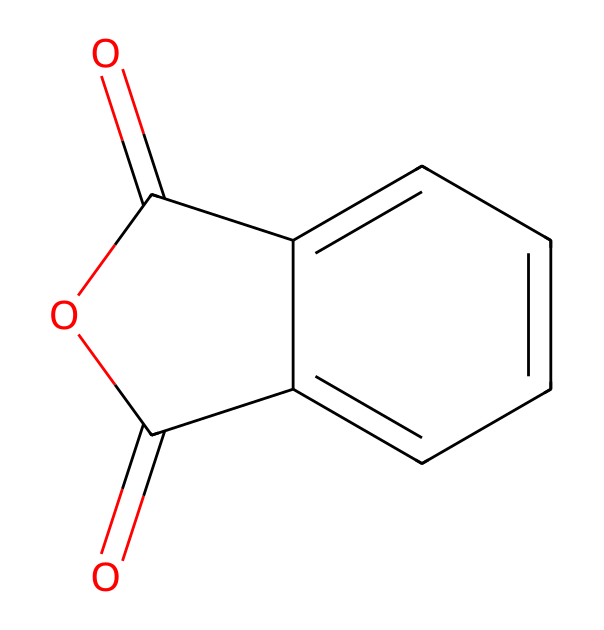What is the name of this chemical? The chemical structure given corresponds to phthalic anhydride, as indicated by the specific arrangement of carbon and oxygen atoms forming an anhydride.
Answer: phthalic anhydride How many carbon atoms are present in this compound? By analyzing the SMILES representation, there are 8 carbon atoms present in the structure, as counted from the carbon elements in the rings and functional groups.
Answer: 8 How many oxygen atoms are in this compound? The structure shows 3 oxygen atoms: 2 in the carboxylic anhydride functional groups and 1 in the carbonyl group, verifiable from the SMILES representation.
Answer: 3 What type of chemical bond connects the carbonyl carbon to oxygen in this compound? The carbonyl carbon in the anhydride structure forms a double bond with oxygen, as evidenced by the presence of the '=' symbol in the SMILES notation.
Answer: double bond What type of compound is phthalic anhydride? As represented in the structure, phthalic anhydride is classified as an acid anhydride because it is formed from the condensation of two carboxylic acids, which is characteristic of acid anhydrides.
Answer: acid anhydride How many rings are present in this chemical structure? The structure contains two fused ring systems, identified in the aromatic part of the molecule, which is characteristic of phthalic compounds.
Answer: 2 What functional group characterizes this chemical compound? The presence of the anhydride functional group, indicated by the carbonyl and the ether-like connection, characterizes this compound specifically as an anhydride.
Answer: anhydride 